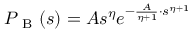Convert formula to latex. <formula><loc_0><loc_0><loc_500><loc_500>P _ { B } ( s ) = A s ^ { \eta } e ^ { - \frac { A } { \eta + 1 } \cdot s ^ { \eta + 1 } }</formula> 